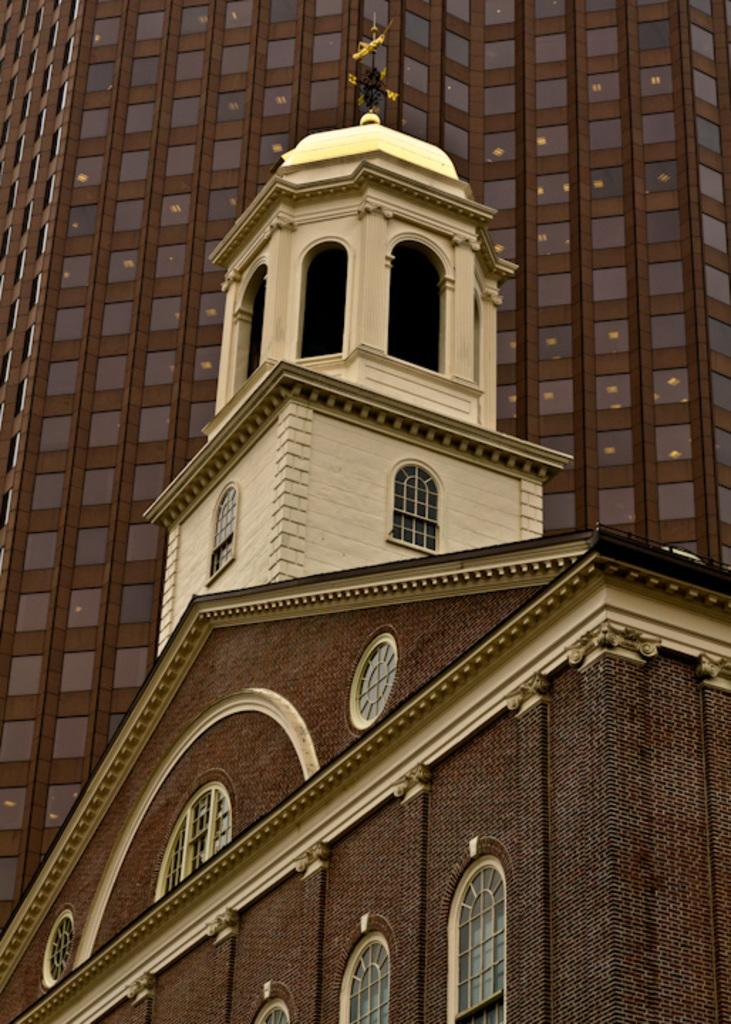What is located at the bottom of the picture? There is a building at the bottom of the picture. What colors can be seen on the building at the bottom? The building at the bottom has a white and brown color. What is visible behind the first building? There is another building behind the first one. What color is the second building? The second building has a brown color. Can you see any goldfish swimming in the picture? There are no goldfish present in the image. What type of plate is being used to serve the food in the picture? There is no plate or food visible in the image. 